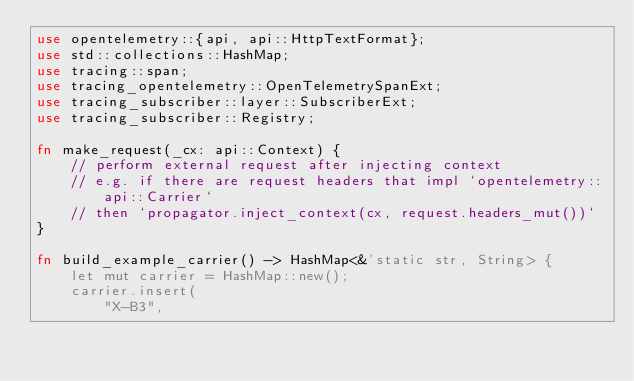Convert code to text. <code><loc_0><loc_0><loc_500><loc_500><_Rust_>use opentelemetry::{api, api::HttpTextFormat};
use std::collections::HashMap;
use tracing::span;
use tracing_opentelemetry::OpenTelemetrySpanExt;
use tracing_subscriber::layer::SubscriberExt;
use tracing_subscriber::Registry;

fn make_request(_cx: api::Context) {
    // perform external request after injecting context
    // e.g. if there are request headers that impl `opentelemetry::api::Carrier`
    // then `propagator.inject_context(cx, request.headers_mut())`
}

fn build_example_carrier() -> HashMap<&'static str, String> {
    let mut carrier = HashMap::new();
    carrier.insert(
        "X-B3",</code> 